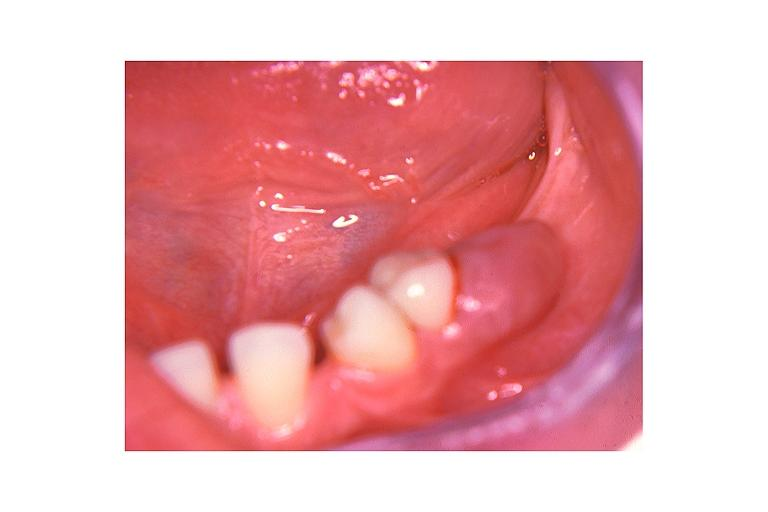what does this image show?
Answer the question using a single word or phrase. Peripheral giant cell lesion 